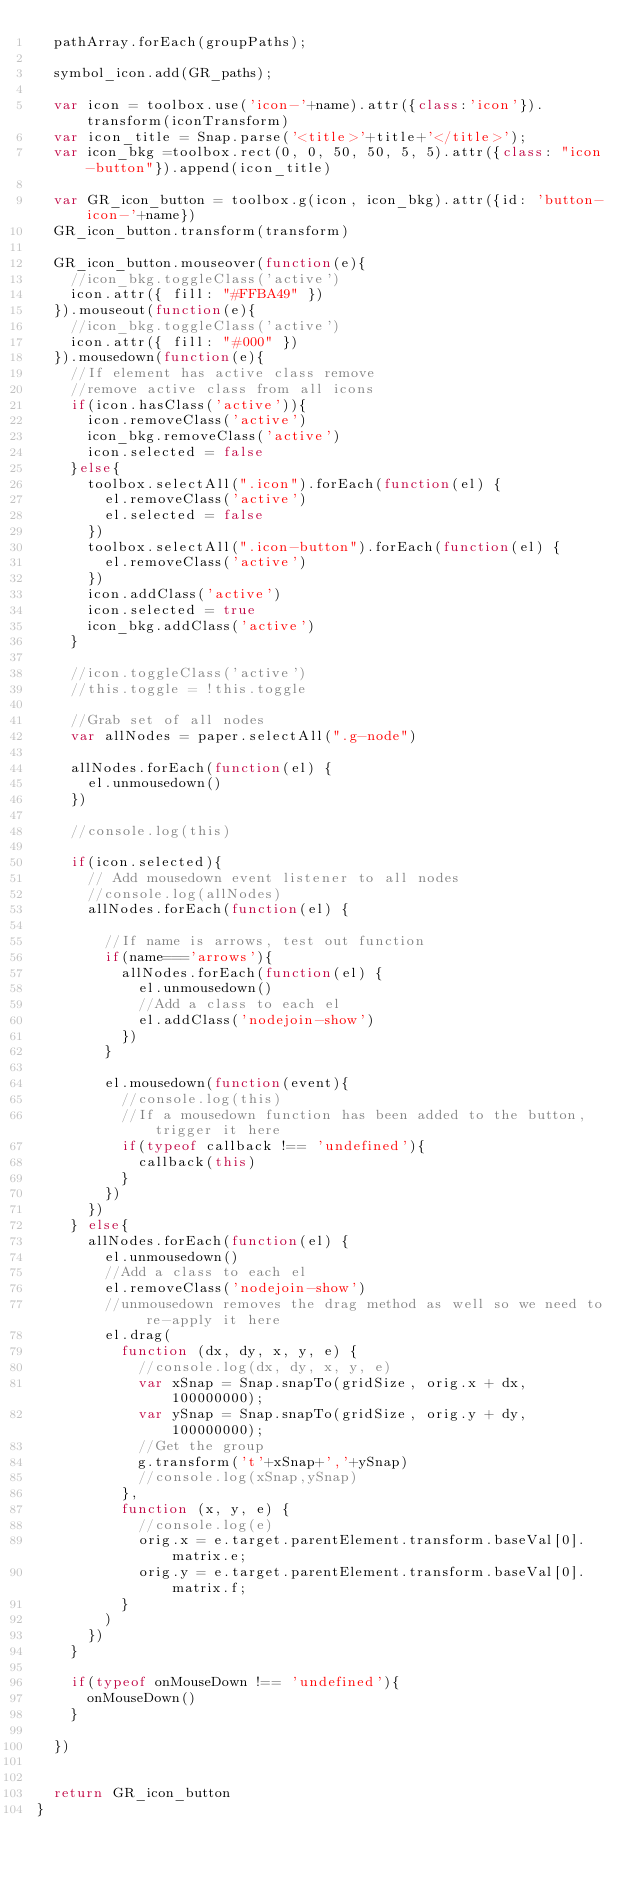<code> <loc_0><loc_0><loc_500><loc_500><_JavaScript_>  pathArray.forEach(groupPaths);

  symbol_icon.add(GR_paths);

  var icon = toolbox.use('icon-'+name).attr({class:'icon'}).transform(iconTransform)
  var icon_title = Snap.parse('<title>'+title+'</title>');
  var icon_bkg =toolbox.rect(0, 0, 50, 50, 5, 5).attr({class: "icon-button"}).append(icon_title)

  var GR_icon_button = toolbox.g(icon, icon_bkg).attr({id: 'button-icon-'+name})
  GR_icon_button.transform(transform)

  GR_icon_button.mouseover(function(e){
    //icon_bkg.toggleClass('active')
    icon.attr({ fill: "#FFBA49" })
  }).mouseout(function(e){
    //icon_bkg.toggleClass('active')
    icon.attr({ fill: "#000" })
  }).mousedown(function(e){
    //If element has active class remove
    //remove active class from all icons
    if(icon.hasClass('active')){
      icon.removeClass('active')
      icon_bkg.removeClass('active')
      icon.selected = false
    }else{
      toolbox.selectAll(".icon").forEach(function(el) {
        el.removeClass('active')
        el.selected = false
      })
      toolbox.selectAll(".icon-button").forEach(function(el) {
        el.removeClass('active')
      })
      icon.addClass('active')
      icon.selected = true
      icon_bkg.addClass('active')
    }

    //icon.toggleClass('active')
    //this.toggle = !this.toggle

    //Grab set of all nodes
    var allNodes = paper.selectAll(".g-node")

    allNodes.forEach(function(el) {
      el.unmousedown()
    })

    //console.log(this)

    if(icon.selected){
      // Add mousedown event listener to all nodes
      //console.log(allNodes)
      allNodes.forEach(function(el) {

        //If name is arrows, test out function
        if(name==='arrows'){
          allNodes.forEach(function(el) {
            el.unmousedown()
            //Add a class to each el
            el.addClass('nodejoin-show')
          })
        }

        el.mousedown(function(event){
          //console.log(this)
          //If a mousedown function has been added to the button, trigger it here
          if(typeof callback !== 'undefined'){
            callback(this)
          }
        })
      })
    } else{
      allNodes.forEach(function(el) {
        el.unmousedown()
        //Add a class to each el
        el.removeClass('nodejoin-show')
        //unmousedown removes the drag method as well so we need to re-apply it here
        el.drag(
          function (dx, dy, x, y, e) {
            //console.log(dx, dy, x, y, e)
            var xSnap = Snap.snapTo(gridSize, orig.x + dx, 100000000);
            var ySnap = Snap.snapTo(gridSize, orig.y + dy, 100000000);
            //Get the group
            g.transform('t'+xSnap+','+ySnap)
            //console.log(xSnap,ySnap)
          },
          function (x, y, e) {
            //console.log(e)
            orig.x = e.target.parentElement.transform.baseVal[0].matrix.e;
            orig.y = e.target.parentElement.transform.baseVal[0].matrix.f;
          }
        )
      })
    }

    if(typeof onMouseDown !== 'undefined'){
      onMouseDown()
    }

  })


  return GR_icon_button
}
</code> 